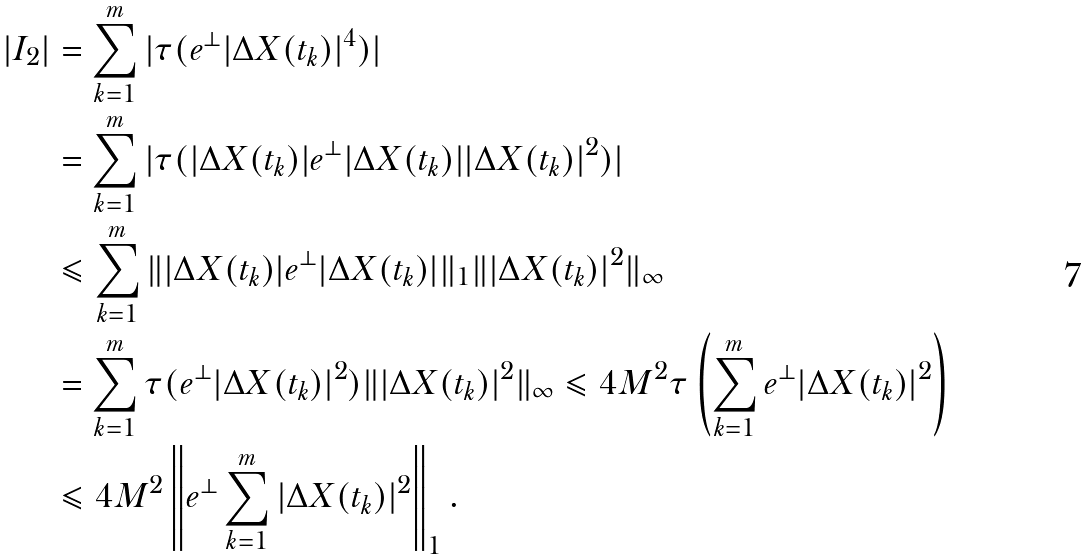<formula> <loc_0><loc_0><loc_500><loc_500>| I _ { 2 } | & = \sum _ { k = 1 } ^ { m } | \tau ( e ^ { \bot } | \Delta X ( t _ { k } ) | ^ { 4 } ) | \\ & = \sum _ { k = 1 } ^ { m } | \tau ( | \Delta X ( t _ { k } ) | e ^ { \bot } | \Delta X ( t _ { k } ) | | \Delta X ( t _ { k } ) | ^ { 2 } ) | \\ & \leqslant \sum _ { k = 1 } ^ { m } \| | \Delta X ( t _ { k } ) | e ^ { \bot } | \Delta X ( t _ { k } ) | \| _ { 1 } \| | \Delta X ( t _ { k } ) | ^ { 2 } \| _ { \infty } \\ & = \sum _ { k = 1 } ^ { m } \tau ( e ^ { \bot } | \Delta X ( t _ { k } ) | ^ { 2 } ) \| | \Delta X ( t _ { k } ) | ^ { 2 } \| _ { \infty } \leqslant 4 M ^ { 2 } \tau \left ( \sum _ { k = 1 } ^ { m } e ^ { \bot } | \Delta X ( t _ { k } ) | ^ { 2 } \right ) \\ & \leqslant 4 M ^ { 2 } \left \| e ^ { \bot } \sum _ { k = 1 } ^ { m } | \Delta X ( t _ { k } ) | ^ { 2 } \right \| _ { 1 } .</formula> 